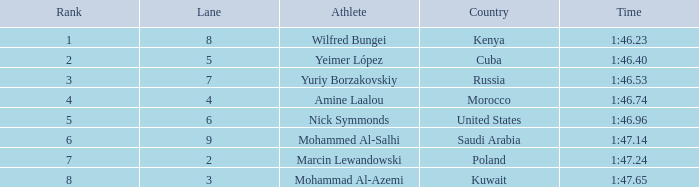What is the Rank of the Athlete with a Time of 1:47.65 and in Lane 3 or larger? None. 